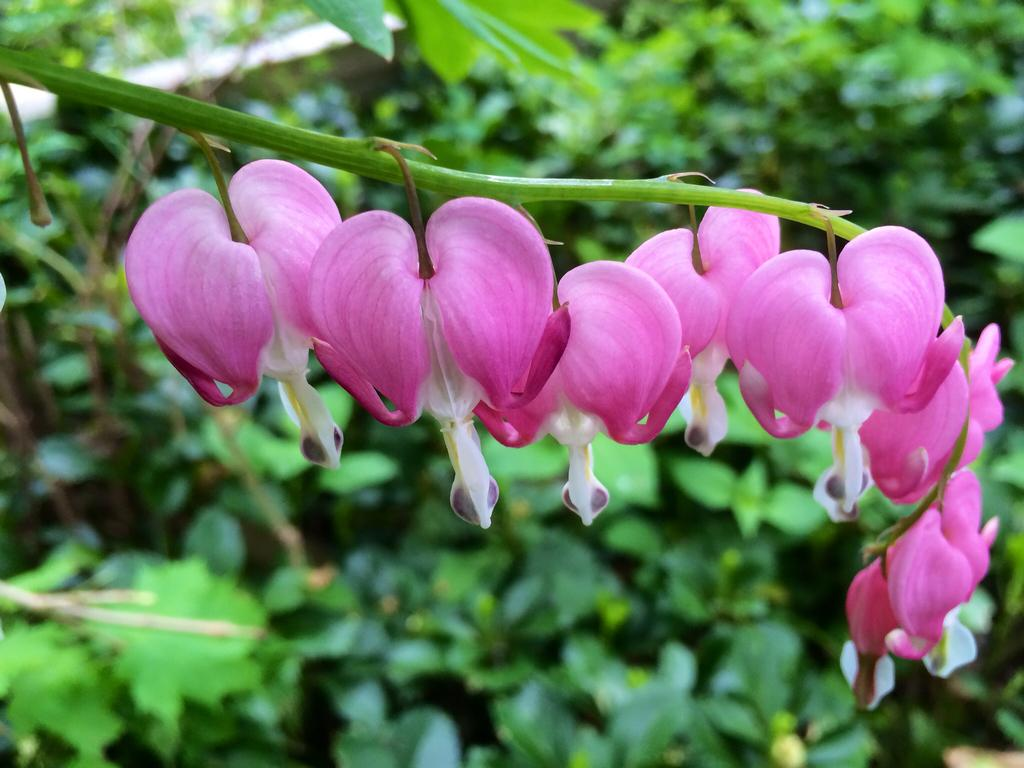What type of flora is present in the image? There are flowers and trees in the image. Can you describe the natural environment depicted in the image? The image features flowers and trees, which suggests a natural setting. What type of wine is being served in the image? There is no wine present in the image; it features flowers and trees. Can you describe the spacecraft visible in the image? There is no spacecraft present in the image; it features flowers and trees. 